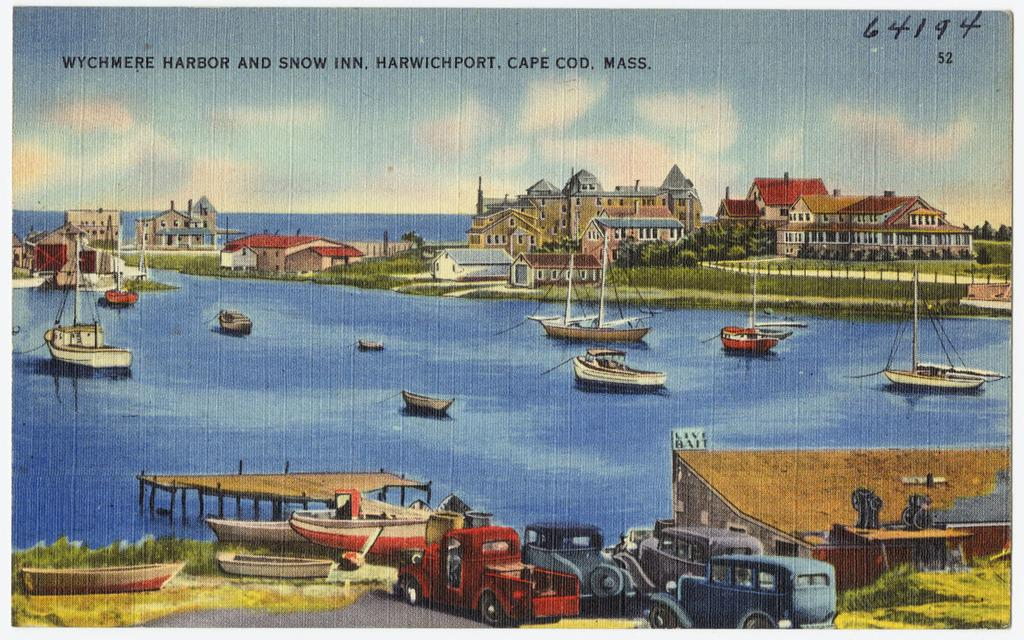What type of image is being described? The image is graphical in nature. What types of transportation are depicted in the image? There are vehicles, ships, and boats in the image. What natural elements can be seen in the image? There are trees and grass in the image. What man-made structures are present in the image? There are buildings in the image. What type of cheese is being used as a collar for the tramp in the image? There is no cheese, collar, or tramp present in the image. 